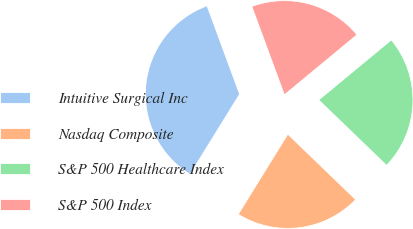Convert chart. <chart><loc_0><loc_0><loc_500><loc_500><pie_chart><fcel>Intuitive Surgical Inc<fcel>Nasdaq Composite<fcel>S&P 500 Healthcare Index<fcel>S&P 500 Index<nl><fcel>35.57%<fcel>21.61%<fcel>23.21%<fcel>19.62%<nl></chart> 